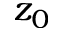<formula> <loc_0><loc_0><loc_500><loc_500>z _ { 0 }</formula> 